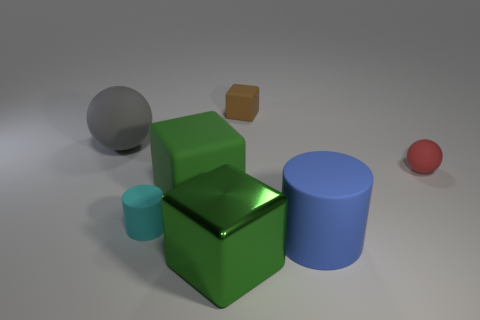Add 1 brown cubes. How many objects exist? 8 Subtract 1 cubes. How many cubes are left? 2 Subtract all big rubber cubes. How many cubes are left? 2 Subtract all blocks. How many objects are left? 4 Subtract all gray shiny cubes. Subtract all cylinders. How many objects are left? 5 Add 3 large matte cubes. How many large matte cubes are left? 4 Add 3 purple matte spheres. How many purple matte spheres exist? 3 Subtract 1 brown cubes. How many objects are left? 6 